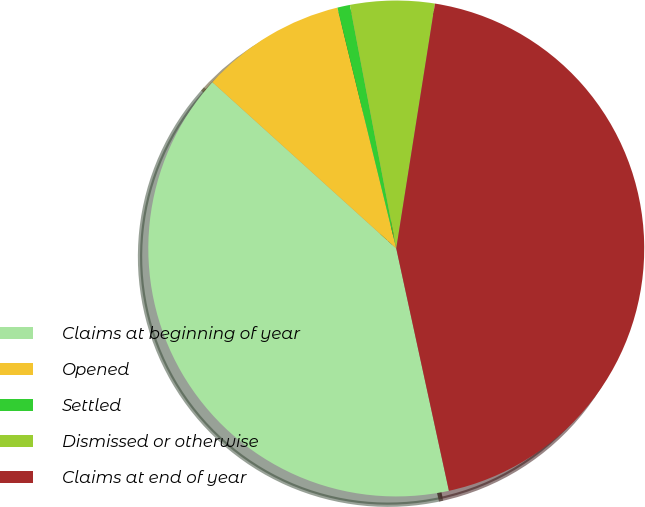<chart> <loc_0><loc_0><loc_500><loc_500><pie_chart><fcel>Claims at beginning of year<fcel>Opened<fcel>Settled<fcel>Dismissed or otherwise<fcel>Claims at end of year<nl><fcel>40.11%<fcel>9.48%<fcel>0.82%<fcel>5.49%<fcel>44.1%<nl></chart> 